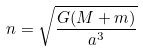<formula> <loc_0><loc_0><loc_500><loc_500>n = \sqrt { \frac { G ( M + m ) } { a ^ { 3 } } }</formula> 